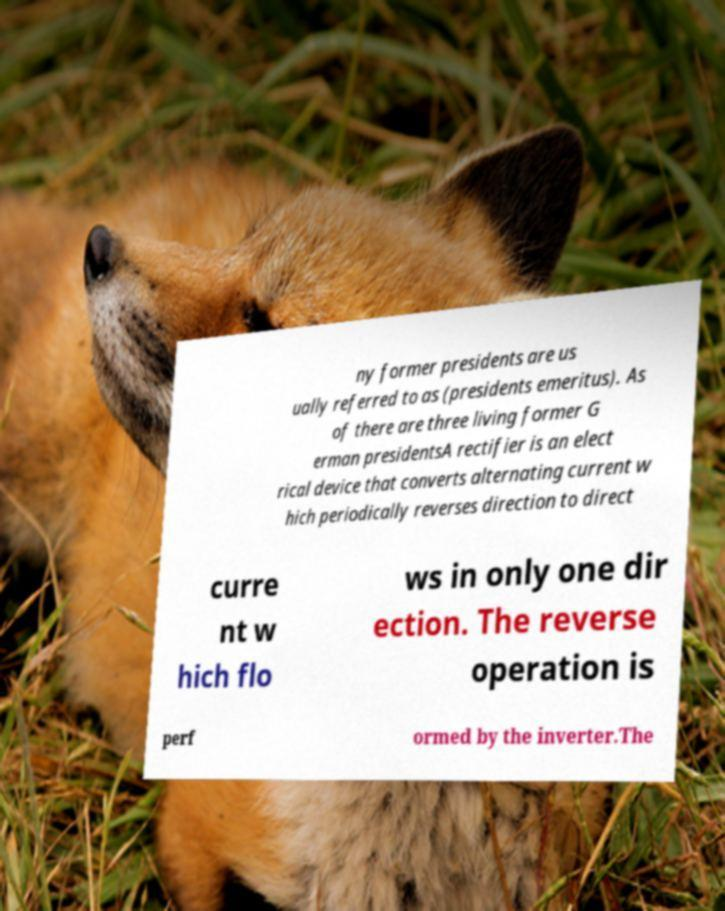For documentation purposes, I need the text within this image transcribed. Could you provide that? ny former presidents are us ually referred to as (presidents emeritus). As of there are three living former G erman presidentsA rectifier is an elect rical device that converts alternating current w hich periodically reverses direction to direct curre nt w hich flo ws in only one dir ection. The reverse operation is perf ormed by the inverter.The 